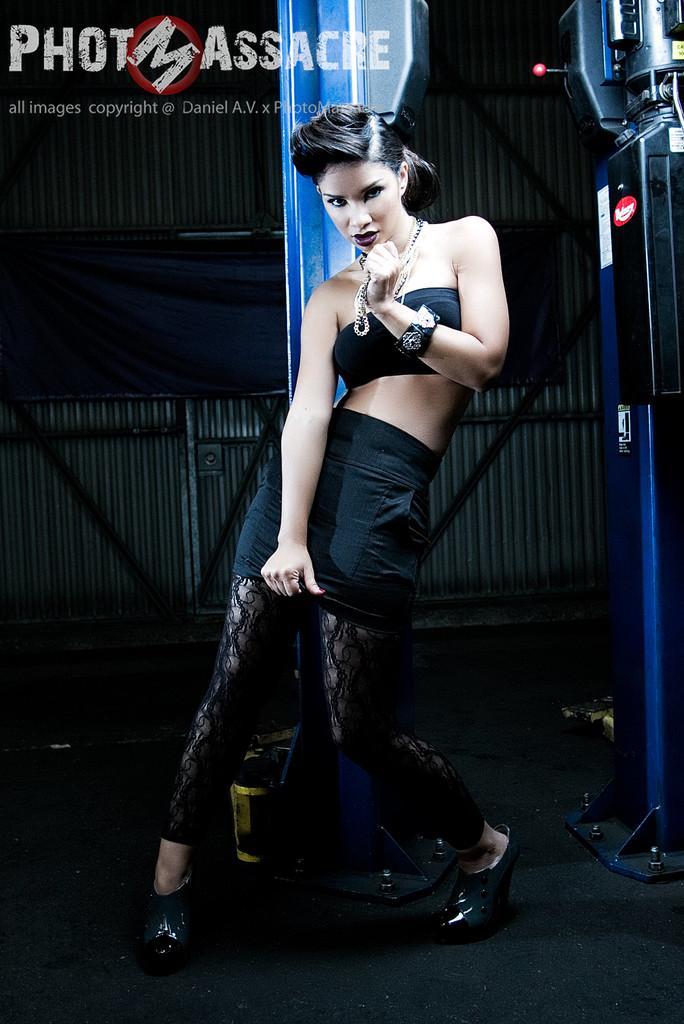Could you give a brief overview of what you see in this image? In this image we can see a lady wearing a black color dress. In the background of the image there is a wall with rods and cloth. To the right side of the image there is some object. At the top of the image there is some text. At the bottom of the image there is floor. 